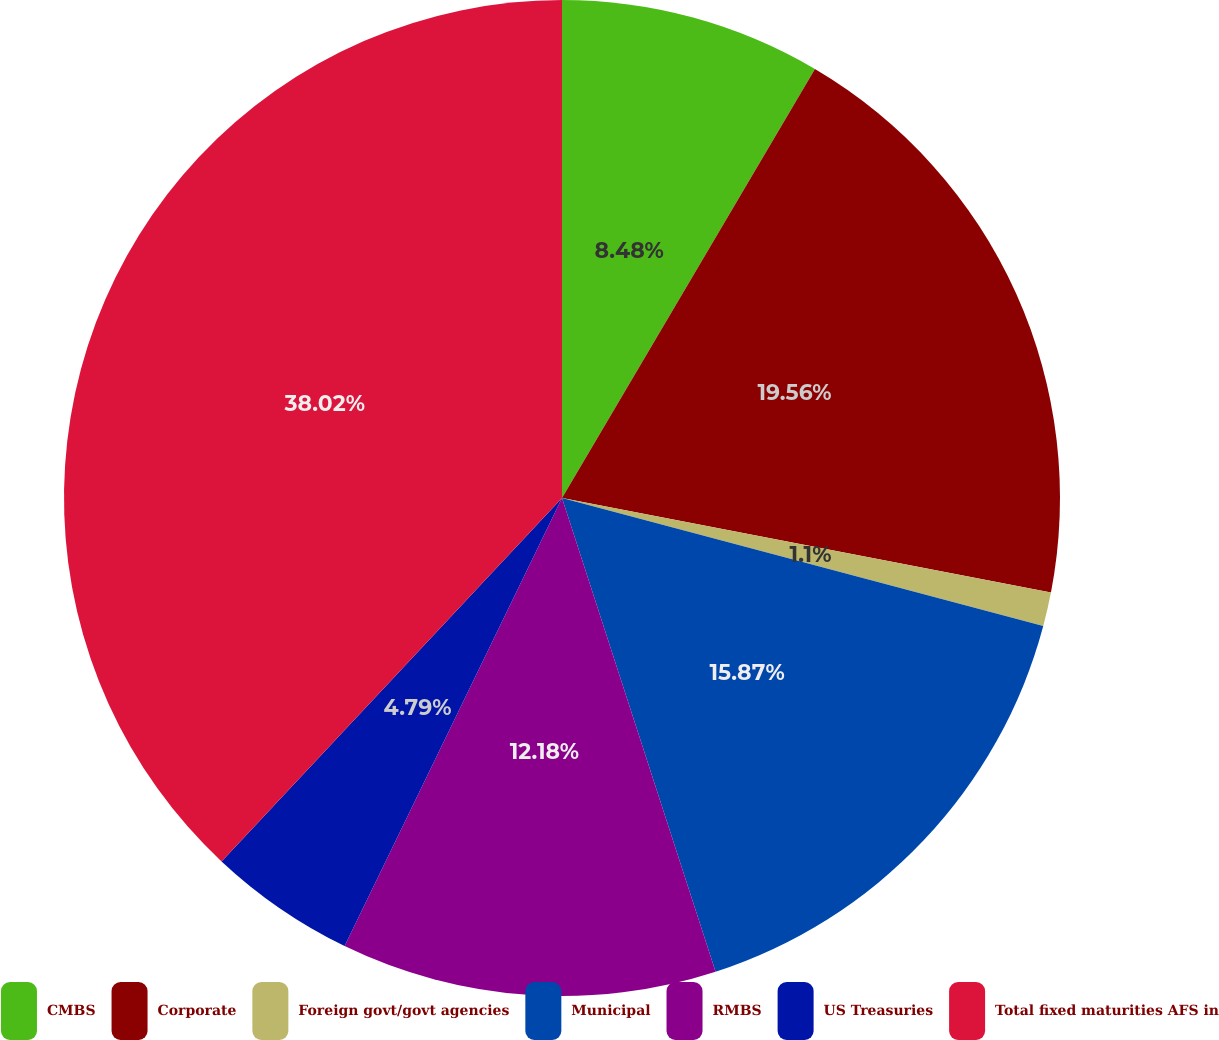<chart> <loc_0><loc_0><loc_500><loc_500><pie_chart><fcel>CMBS<fcel>Corporate<fcel>Foreign govt/govt agencies<fcel>Municipal<fcel>RMBS<fcel>US Treasuries<fcel>Total fixed maturities AFS in<nl><fcel>8.48%<fcel>19.56%<fcel>1.1%<fcel>15.87%<fcel>12.18%<fcel>4.79%<fcel>38.02%<nl></chart> 